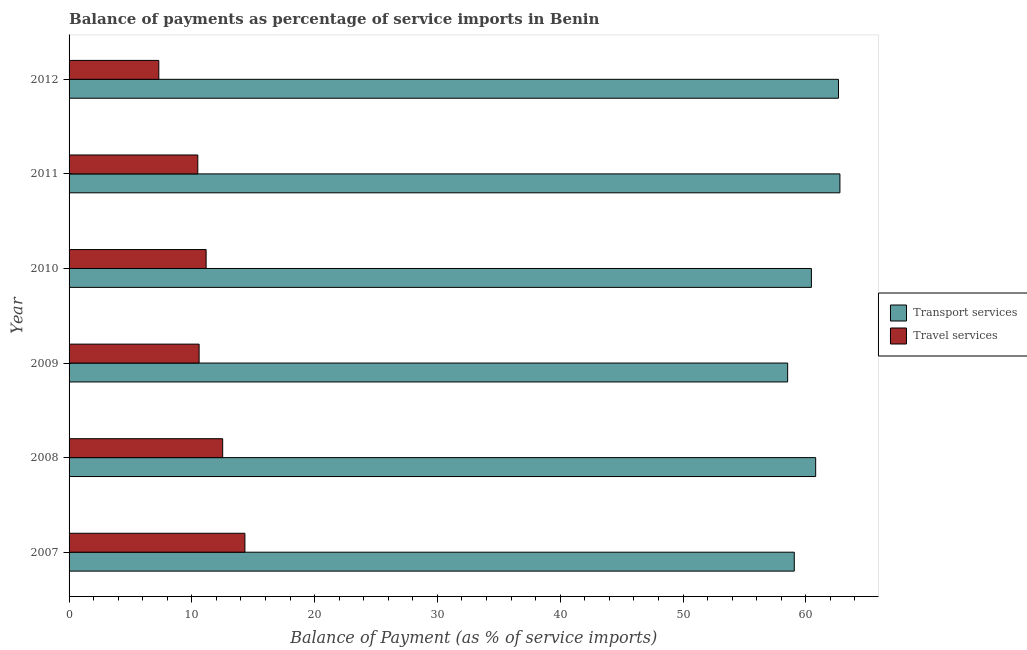Are the number of bars on each tick of the Y-axis equal?
Your answer should be compact. Yes. How many bars are there on the 5th tick from the top?
Ensure brevity in your answer.  2. What is the label of the 3rd group of bars from the top?
Offer a terse response. 2010. In how many cases, is the number of bars for a given year not equal to the number of legend labels?
Provide a short and direct response. 0. What is the balance of payments of transport services in 2007?
Provide a short and direct response. 59.06. Across all years, what is the maximum balance of payments of travel services?
Your response must be concise. 14.32. Across all years, what is the minimum balance of payments of transport services?
Provide a succinct answer. 58.52. In which year was the balance of payments of transport services maximum?
Give a very brief answer. 2011. What is the total balance of payments of travel services in the graph?
Offer a terse response. 66.38. What is the difference between the balance of payments of travel services in 2009 and that in 2010?
Offer a terse response. -0.57. What is the difference between the balance of payments of travel services in 2008 and the balance of payments of transport services in 2007?
Give a very brief answer. -46.55. What is the average balance of payments of travel services per year?
Offer a very short reply. 11.06. In the year 2007, what is the difference between the balance of payments of travel services and balance of payments of transport services?
Your response must be concise. -44.74. In how many years, is the balance of payments of travel services greater than 48 %?
Provide a short and direct response. 0. What is the ratio of the balance of payments of travel services in 2011 to that in 2012?
Provide a short and direct response. 1.43. What is the difference between the highest and the second highest balance of payments of travel services?
Make the answer very short. 1.81. What is the difference between the highest and the lowest balance of payments of travel services?
Offer a very short reply. 7.01. In how many years, is the balance of payments of travel services greater than the average balance of payments of travel services taken over all years?
Keep it short and to the point. 3. What does the 1st bar from the top in 2011 represents?
Give a very brief answer. Travel services. What does the 1st bar from the bottom in 2008 represents?
Offer a terse response. Transport services. Are all the bars in the graph horizontal?
Give a very brief answer. Yes. What is the difference between two consecutive major ticks on the X-axis?
Keep it short and to the point. 10. Are the values on the major ticks of X-axis written in scientific E-notation?
Offer a terse response. No. Does the graph contain any zero values?
Ensure brevity in your answer.  No. Where does the legend appear in the graph?
Make the answer very short. Center right. What is the title of the graph?
Your answer should be very brief. Balance of payments as percentage of service imports in Benin. Does "Excluding technical cooperation" appear as one of the legend labels in the graph?
Your answer should be compact. No. What is the label or title of the X-axis?
Give a very brief answer. Balance of Payment (as % of service imports). What is the Balance of Payment (as % of service imports) of Transport services in 2007?
Ensure brevity in your answer.  59.06. What is the Balance of Payment (as % of service imports) of Travel services in 2007?
Provide a short and direct response. 14.32. What is the Balance of Payment (as % of service imports) of Transport services in 2008?
Provide a succinct answer. 60.81. What is the Balance of Payment (as % of service imports) of Travel services in 2008?
Ensure brevity in your answer.  12.51. What is the Balance of Payment (as % of service imports) of Transport services in 2009?
Make the answer very short. 58.52. What is the Balance of Payment (as % of service imports) of Travel services in 2009?
Give a very brief answer. 10.59. What is the Balance of Payment (as % of service imports) of Transport services in 2010?
Your answer should be very brief. 60.46. What is the Balance of Payment (as % of service imports) of Travel services in 2010?
Offer a terse response. 11.16. What is the Balance of Payment (as % of service imports) of Transport services in 2011?
Keep it short and to the point. 62.78. What is the Balance of Payment (as % of service imports) in Travel services in 2011?
Offer a terse response. 10.48. What is the Balance of Payment (as % of service imports) of Transport services in 2012?
Ensure brevity in your answer.  62.66. What is the Balance of Payment (as % of service imports) in Travel services in 2012?
Offer a terse response. 7.31. Across all years, what is the maximum Balance of Payment (as % of service imports) of Transport services?
Provide a succinct answer. 62.78. Across all years, what is the maximum Balance of Payment (as % of service imports) in Travel services?
Offer a very short reply. 14.32. Across all years, what is the minimum Balance of Payment (as % of service imports) in Transport services?
Provide a short and direct response. 58.52. Across all years, what is the minimum Balance of Payment (as % of service imports) in Travel services?
Your response must be concise. 7.31. What is the total Balance of Payment (as % of service imports) of Transport services in the graph?
Provide a short and direct response. 364.29. What is the total Balance of Payment (as % of service imports) of Travel services in the graph?
Provide a succinct answer. 66.38. What is the difference between the Balance of Payment (as % of service imports) in Transport services in 2007 and that in 2008?
Make the answer very short. -1.74. What is the difference between the Balance of Payment (as % of service imports) of Travel services in 2007 and that in 2008?
Your answer should be very brief. 1.81. What is the difference between the Balance of Payment (as % of service imports) of Transport services in 2007 and that in 2009?
Your response must be concise. 0.54. What is the difference between the Balance of Payment (as % of service imports) of Travel services in 2007 and that in 2009?
Give a very brief answer. 3.73. What is the difference between the Balance of Payment (as % of service imports) of Transport services in 2007 and that in 2010?
Give a very brief answer. -1.39. What is the difference between the Balance of Payment (as % of service imports) of Travel services in 2007 and that in 2010?
Keep it short and to the point. 3.16. What is the difference between the Balance of Payment (as % of service imports) in Transport services in 2007 and that in 2011?
Your answer should be compact. -3.72. What is the difference between the Balance of Payment (as % of service imports) in Travel services in 2007 and that in 2011?
Ensure brevity in your answer.  3.84. What is the difference between the Balance of Payment (as % of service imports) of Transport services in 2007 and that in 2012?
Keep it short and to the point. -3.6. What is the difference between the Balance of Payment (as % of service imports) in Travel services in 2007 and that in 2012?
Ensure brevity in your answer.  7.01. What is the difference between the Balance of Payment (as % of service imports) of Transport services in 2008 and that in 2009?
Make the answer very short. 2.28. What is the difference between the Balance of Payment (as % of service imports) of Travel services in 2008 and that in 2009?
Ensure brevity in your answer.  1.92. What is the difference between the Balance of Payment (as % of service imports) in Transport services in 2008 and that in 2010?
Your answer should be compact. 0.35. What is the difference between the Balance of Payment (as % of service imports) in Travel services in 2008 and that in 2010?
Keep it short and to the point. 1.35. What is the difference between the Balance of Payment (as % of service imports) of Transport services in 2008 and that in 2011?
Provide a succinct answer. -1.97. What is the difference between the Balance of Payment (as % of service imports) of Travel services in 2008 and that in 2011?
Provide a short and direct response. 2.03. What is the difference between the Balance of Payment (as % of service imports) of Transport services in 2008 and that in 2012?
Your response must be concise. -1.86. What is the difference between the Balance of Payment (as % of service imports) of Travel services in 2008 and that in 2012?
Provide a succinct answer. 5.2. What is the difference between the Balance of Payment (as % of service imports) of Transport services in 2009 and that in 2010?
Your response must be concise. -1.93. What is the difference between the Balance of Payment (as % of service imports) in Travel services in 2009 and that in 2010?
Your response must be concise. -0.57. What is the difference between the Balance of Payment (as % of service imports) of Transport services in 2009 and that in 2011?
Give a very brief answer. -4.26. What is the difference between the Balance of Payment (as % of service imports) of Travel services in 2009 and that in 2011?
Offer a very short reply. 0.11. What is the difference between the Balance of Payment (as % of service imports) of Transport services in 2009 and that in 2012?
Ensure brevity in your answer.  -4.14. What is the difference between the Balance of Payment (as % of service imports) of Travel services in 2009 and that in 2012?
Provide a succinct answer. 3.28. What is the difference between the Balance of Payment (as % of service imports) in Transport services in 2010 and that in 2011?
Offer a very short reply. -2.32. What is the difference between the Balance of Payment (as % of service imports) of Travel services in 2010 and that in 2011?
Offer a terse response. 0.68. What is the difference between the Balance of Payment (as % of service imports) of Transport services in 2010 and that in 2012?
Your answer should be compact. -2.21. What is the difference between the Balance of Payment (as % of service imports) of Travel services in 2010 and that in 2012?
Your answer should be very brief. 3.85. What is the difference between the Balance of Payment (as % of service imports) in Transport services in 2011 and that in 2012?
Provide a succinct answer. 0.12. What is the difference between the Balance of Payment (as % of service imports) of Travel services in 2011 and that in 2012?
Your answer should be compact. 3.17. What is the difference between the Balance of Payment (as % of service imports) in Transport services in 2007 and the Balance of Payment (as % of service imports) in Travel services in 2008?
Ensure brevity in your answer.  46.55. What is the difference between the Balance of Payment (as % of service imports) of Transport services in 2007 and the Balance of Payment (as % of service imports) of Travel services in 2009?
Ensure brevity in your answer.  48.47. What is the difference between the Balance of Payment (as % of service imports) in Transport services in 2007 and the Balance of Payment (as % of service imports) in Travel services in 2010?
Ensure brevity in your answer.  47.9. What is the difference between the Balance of Payment (as % of service imports) in Transport services in 2007 and the Balance of Payment (as % of service imports) in Travel services in 2011?
Keep it short and to the point. 48.58. What is the difference between the Balance of Payment (as % of service imports) of Transport services in 2007 and the Balance of Payment (as % of service imports) of Travel services in 2012?
Provide a short and direct response. 51.75. What is the difference between the Balance of Payment (as % of service imports) in Transport services in 2008 and the Balance of Payment (as % of service imports) in Travel services in 2009?
Offer a terse response. 50.21. What is the difference between the Balance of Payment (as % of service imports) in Transport services in 2008 and the Balance of Payment (as % of service imports) in Travel services in 2010?
Give a very brief answer. 49.64. What is the difference between the Balance of Payment (as % of service imports) of Transport services in 2008 and the Balance of Payment (as % of service imports) of Travel services in 2011?
Give a very brief answer. 50.32. What is the difference between the Balance of Payment (as % of service imports) in Transport services in 2008 and the Balance of Payment (as % of service imports) in Travel services in 2012?
Your response must be concise. 53.5. What is the difference between the Balance of Payment (as % of service imports) in Transport services in 2009 and the Balance of Payment (as % of service imports) in Travel services in 2010?
Make the answer very short. 47.36. What is the difference between the Balance of Payment (as % of service imports) of Transport services in 2009 and the Balance of Payment (as % of service imports) of Travel services in 2011?
Provide a succinct answer. 48.04. What is the difference between the Balance of Payment (as % of service imports) of Transport services in 2009 and the Balance of Payment (as % of service imports) of Travel services in 2012?
Keep it short and to the point. 51.22. What is the difference between the Balance of Payment (as % of service imports) of Transport services in 2010 and the Balance of Payment (as % of service imports) of Travel services in 2011?
Ensure brevity in your answer.  49.97. What is the difference between the Balance of Payment (as % of service imports) in Transport services in 2010 and the Balance of Payment (as % of service imports) in Travel services in 2012?
Your answer should be compact. 53.15. What is the difference between the Balance of Payment (as % of service imports) in Transport services in 2011 and the Balance of Payment (as % of service imports) in Travel services in 2012?
Offer a terse response. 55.47. What is the average Balance of Payment (as % of service imports) of Transport services per year?
Offer a terse response. 60.72. What is the average Balance of Payment (as % of service imports) of Travel services per year?
Offer a terse response. 11.06. In the year 2007, what is the difference between the Balance of Payment (as % of service imports) of Transport services and Balance of Payment (as % of service imports) of Travel services?
Offer a very short reply. 44.74. In the year 2008, what is the difference between the Balance of Payment (as % of service imports) in Transport services and Balance of Payment (as % of service imports) in Travel services?
Offer a very short reply. 48.29. In the year 2009, what is the difference between the Balance of Payment (as % of service imports) in Transport services and Balance of Payment (as % of service imports) in Travel services?
Give a very brief answer. 47.93. In the year 2010, what is the difference between the Balance of Payment (as % of service imports) in Transport services and Balance of Payment (as % of service imports) in Travel services?
Make the answer very short. 49.3. In the year 2011, what is the difference between the Balance of Payment (as % of service imports) in Transport services and Balance of Payment (as % of service imports) in Travel services?
Provide a succinct answer. 52.3. In the year 2012, what is the difference between the Balance of Payment (as % of service imports) in Transport services and Balance of Payment (as % of service imports) in Travel services?
Your answer should be compact. 55.35. What is the ratio of the Balance of Payment (as % of service imports) of Transport services in 2007 to that in 2008?
Offer a very short reply. 0.97. What is the ratio of the Balance of Payment (as % of service imports) in Travel services in 2007 to that in 2008?
Offer a very short reply. 1.14. What is the ratio of the Balance of Payment (as % of service imports) in Transport services in 2007 to that in 2009?
Keep it short and to the point. 1.01. What is the ratio of the Balance of Payment (as % of service imports) in Travel services in 2007 to that in 2009?
Your response must be concise. 1.35. What is the ratio of the Balance of Payment (as % of service imports) of Transport services in 2007 to that in 2010?
Offer a terse response. 0.98. What is the ratio of the Balance of Payment (as % of service imports) of Travel services in 2007 to that in 2010?
Your answer should be compact. 1.28. What is the ratio of the Balance of Payment (as % of service imports) of Transport services in 2007 to that in 2011?
Your answer should be very brief. 0.94. What is the ratio of the Balance of Payment (as % of service imports) of Travel services in 2007 to that in 2011?
Your answer should be very brief. 1.37. What is the ratio of the Balance of Payment (as % of service imports) of Transport services in 2007 to that in 2012?
Keep it short and to the point. 0.94. What is the ratio of the Balance of Payment (as % of service imports) of Travel services in 2007 to that in 2012?
Your answer should be compact. 1.96. What is the ratio of the Balance of Payment (as % of service imports) of Transport services in 2008 to that in 2009?
Your answer should be compact. 1.04. What is the ratio of the Balance of Payment (as % of service imports) in Travel services in 2008 to that in 2009?
Provide a succinct answer. 1.18. What is the ratio of the Balance of Payment (as % of service imports) in Transport services in 2008 to that in 2010?
Your response must be concise. 1.01. What is the ratio of the Balance of Payment (as % of service imports) of Travel services in 2008 to that in 2010?
Provide a short and direct response. 1.12. What is the ratio of the Balance of Payment (as % of service imports) in Transport services in 2008 to that in 2011?
Offer a very short reply. 0.97. What is the ratio of the Balance of Payment (as % of service imports) of Travel services in 2008 to that in 2011?
Your answer should be very brief. 1.19. What is the ratio of the Balance of Payment (as % of service imports) in Transport services in 2008 to that in 2012?
Give a very brief answer. 0.97. What is the ratio of the Balance of Payment (as % of service imports) in Travel services in 2008 to that in 2012?
Offer a very short reply. 1.71. What is the ratio of the Balance of Payment (as % of service imports) of Travel services in 2009 to that in 2010?
Your answer should be compact. 0.95. What is the ratio of the Balance of Payment (as % of service imports) in Transport services in 2009 to that in 2011?
Your answer should be compact. 0.93. What is the ratio of the Balance of Payment (as % of service imports) in Travel services in 2009 to that in 2011?
Offer a terse response. 1.01. What is the ratio of the Balance of Payment (as % of service imports) in Transport services in 2009 to that in 2012?
Make the answer very short. 0.93. What is the ratio of the Balance of Payment (as % of service imports) in Travel services in 2009 to that in 2012?
Keep it short and to the point. 1.45. What is the ratio of the Balance of Payment (as % of service imports) in Transport services in 2010 to that in 2011?
Keep it short and to the point. 0.96. What is the ratio of the Balance of Payment (as % of service imports) of Travel services in 2010 to that in 2011?
Ensure brevity in your answer.  1.06. What is the ratio of the Balance of Payment (as % of service imports) of Transport services in 2010 to that in 2012?
Offer a terse response. 0.96. What is the ratio of the Balance of Payment (as % of service imports) of Travel services in 2010 to that in 2012?
Provide a short and direct response. 1.53. What is the ratio of the Balance of Payment (as % of service imports) in Transport services in 2011 to that in 2012?
Make the answer very short. 1. What is the ratio of the Balance of Payment (as % of service imports) of Travel services in 2011 to that in 2012?
Your answer should be very brief. 1.43. What is the difference between the highest and the second highest Balance of Payment (as % of service imports) in Transport services?
Provide a short and direct response. 0.12. What is the difference between the highest and the second highest Balance of Payment (as % of service imports) of Travel services?
Provide a succinct answer. 1.81. What is the difference between the highest and the lowest Balance of Payment (as % of service imports) in Transport services?
Your answer should be compact. 4.26. What is the difference between the highest and the lowest Balance of Payment (as % of service imports) in Travel services?
Ensure brevity in your answer.  7.01. 